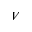<formula> <loc_0><loc_0><loc_500><loc_500>V</formula> 